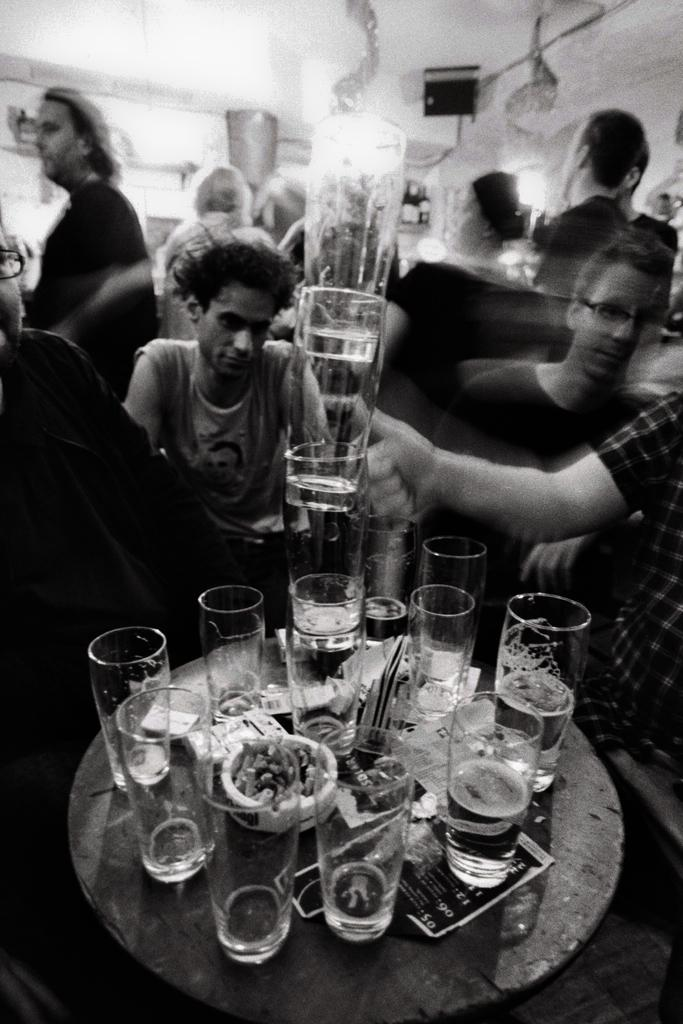What is the color scheme of the image? The image is black and white. What objects are on the table in the image? There are glasses on a table in the image. What are the people in the image doing? The people are sitting around the table. What can be seen behind the table in the image? The background of the image is a wall. Can you tell me how many legs the paint has in the image? There is no paint present in the image, and therefore no legs can be attributed to it. 